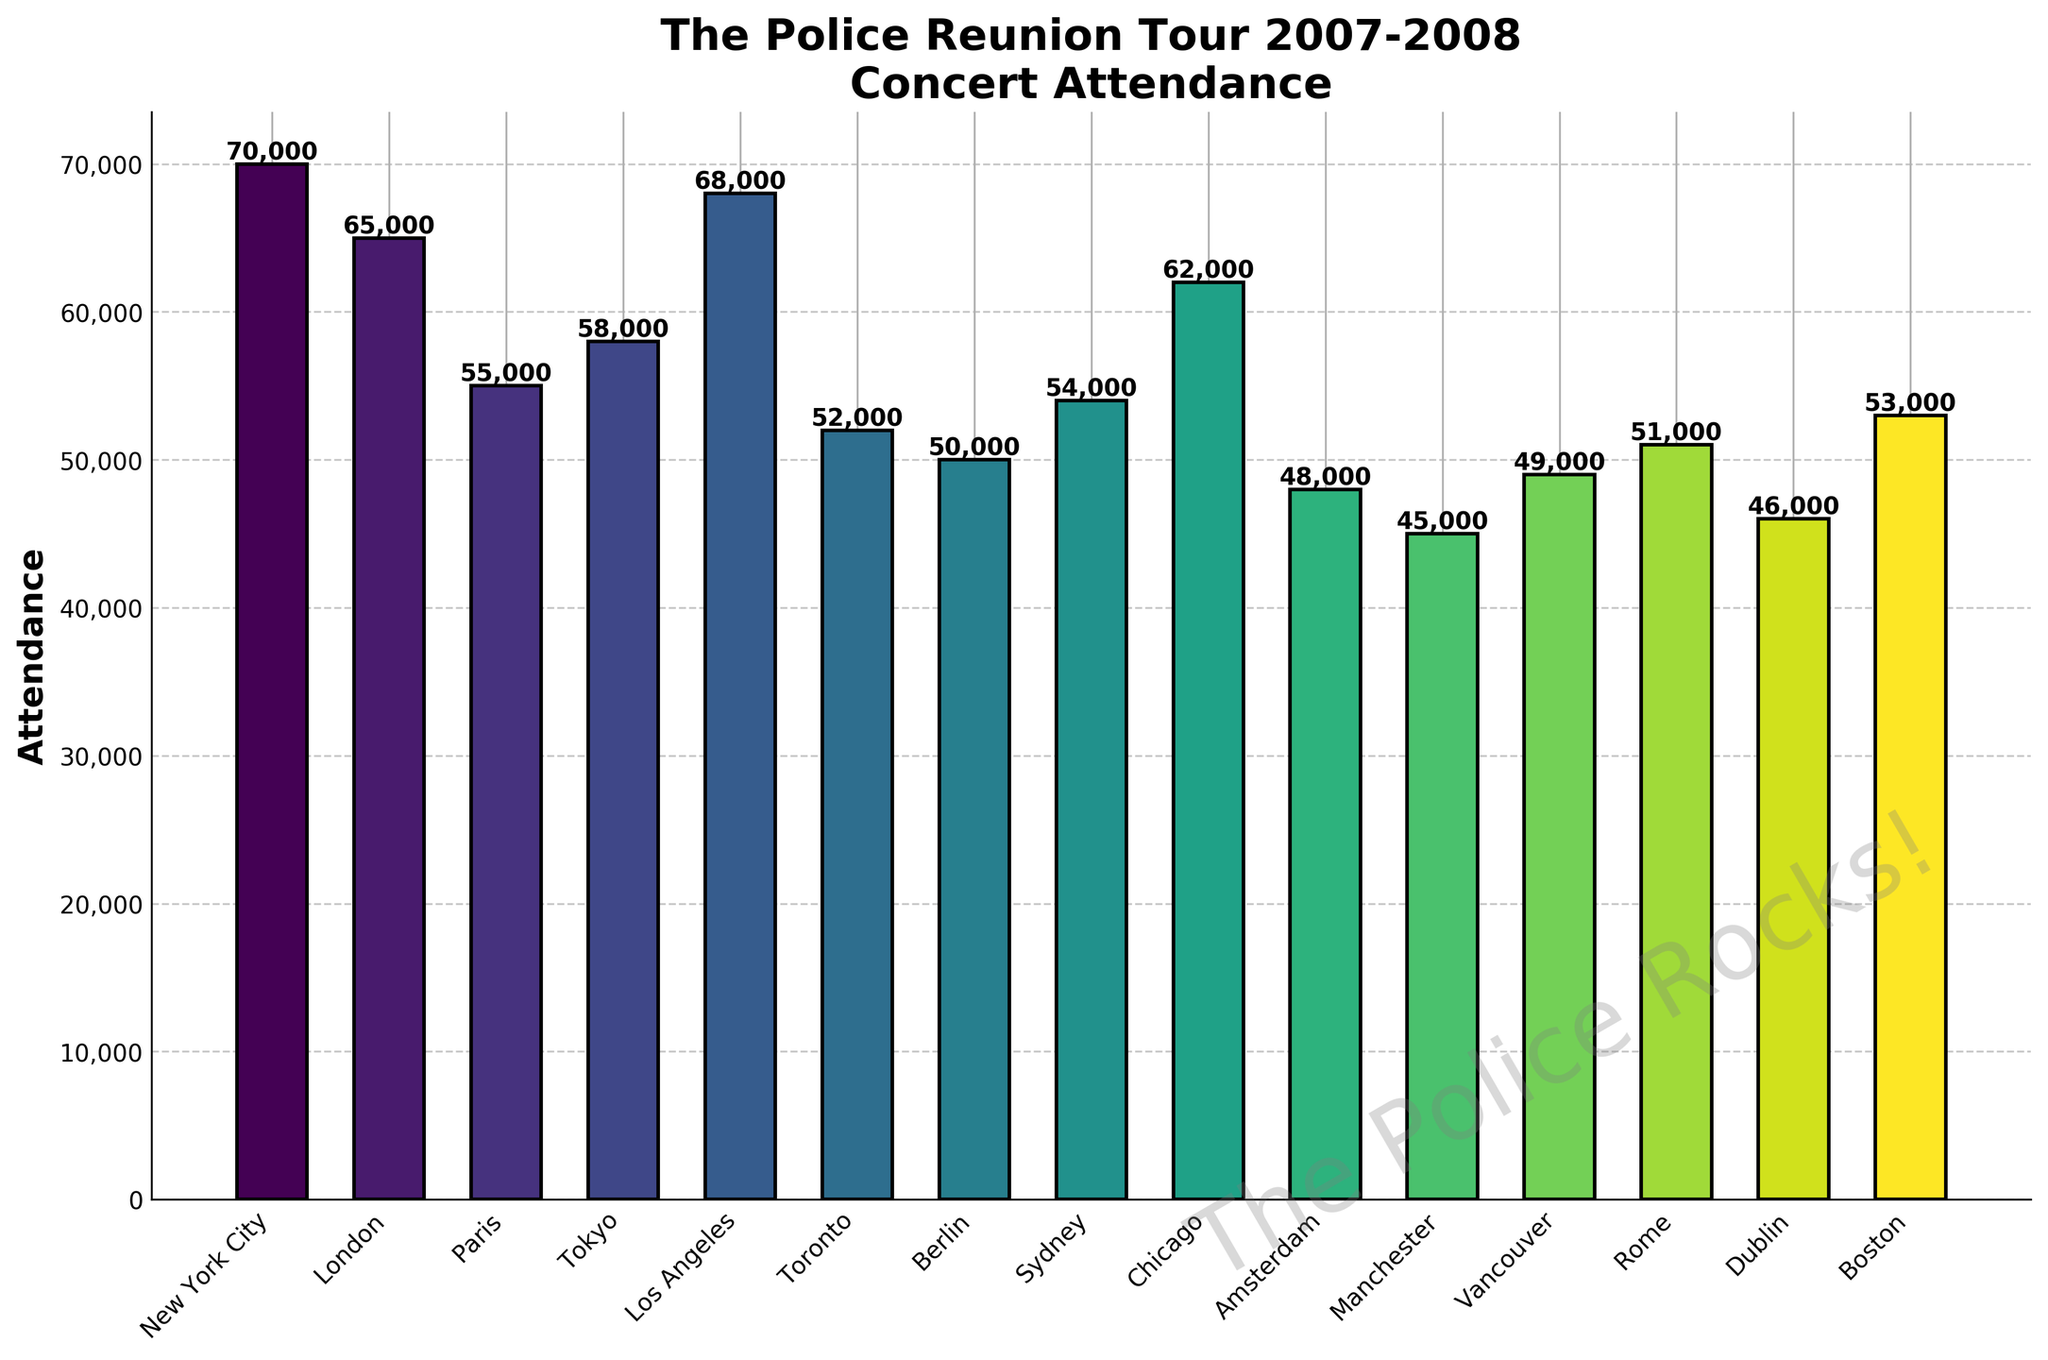Which city had the highest concert attendance? Identify the tallest bar in the plot, which represents the city with the most concert attendees. The bar for New York City is the tallest.
Answer: New York City Which city had a smaller attendance than Sydney but larger than Amsterdam? Locate the bars for Sydney and Amsterdam. Then, find the bar that falls in between these heights. Sydney has an attendance of 54,000, and Amsterdam has 48,000. The only bar in between these values is for Vancouver with 49,000.
Answer: Vancouver What is the total concert attendance for London and Tokyo combined? Sum the attendance figures for London (65,000) and Tokyo (58,000). 65,000 + 58,000 = 123,000.
Answer: 123,000 Which city had the lowest concert attendance? Identify the shortest bar in the plot, which represents the city with the fewest concert attendees. The bar for Manchester is the shortest with 45,000.
Answer: Manchester What is the difference in attendance between Los Angeles and Rome? Calculate the difference between the attendance figures for Los Angeles (68,000) and Rome (51,000). 68,000 - 51,000 = 17,000.
Answer: 17,000 What is the median attendance value of all cities? List all attendance values in ascending order and find the middle value. The ordered list is [45,000, 46,000, 48,000, 49,000, 50,000, 51,000, 52,000, 53,000, 54,000, 55,000, 58,000, 62,000, 65,000, 68,000, 70,000]. The median is the middle value of 52,000.
Answer: 52,000 How much greater was the attendance in New York City compared to Berlin? Calculate the difference between New York City's attendance (70,000) and Berlin's attendance (50,000). 70,000 - 50,000 = 20,000.
Answer: 20,000 Which city has a lighter color bar than the bar for Tokyo? Identify the color gradient used and locate Tokyo's bar. Since the color gradient gets lighter from bottom to top and Tokyo is near the lower middle, bars below Tokyo's bar height (58,000) are lighter. An example is Sydney (54,000).
Answer: Sydney What is the average attendance across all cities? Sum the attendance values and divide by the number of cities. Total attendance: 70000 + 65000 + 55000 + 58000 + 68000 + 52000 + 50000 + 54000 + 62000 + 48000 + 45000 + 49000 + 51000 + 46000 + 53000 = 793,000. Number of cities: 15. Average attendance = 793,000 / 15 = 52,867.
Answer: 52,867 